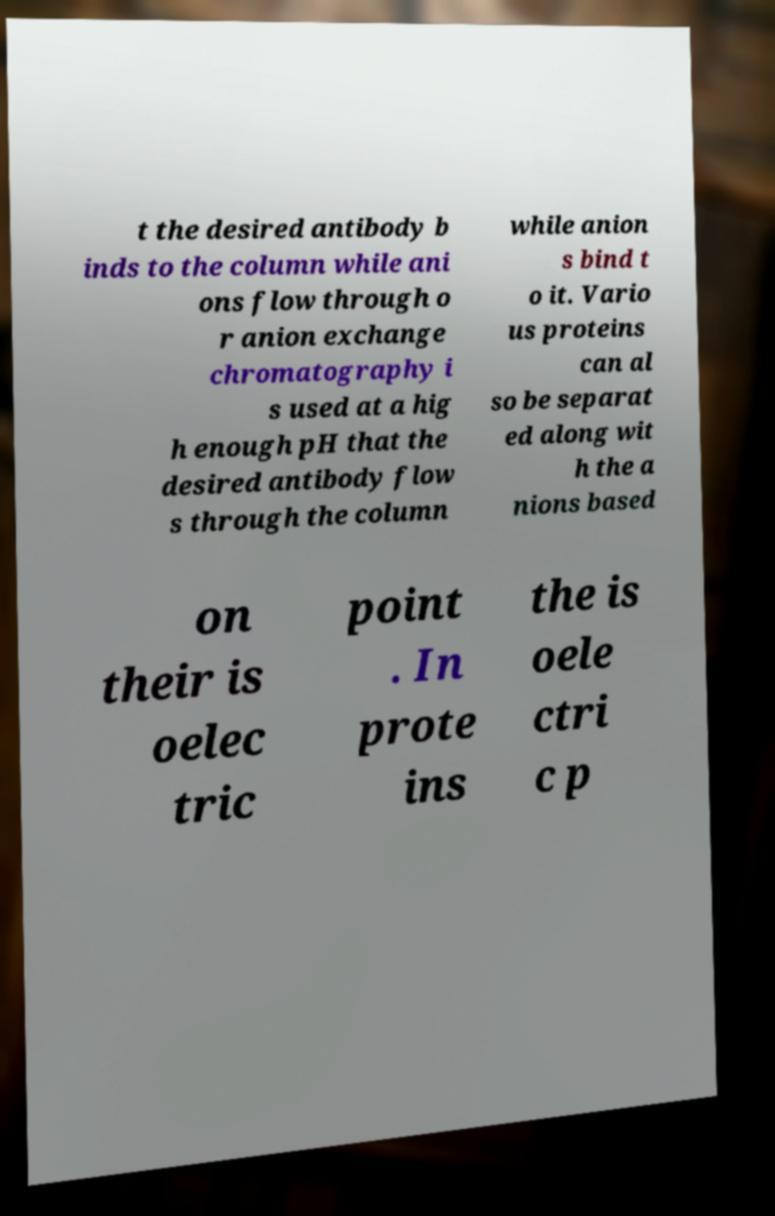Can you accurately transcribe the text from the provided image for me? t the desired antibody b inds to the column while ani ons flow through o r anion exchange chromatography i s used at a hig h enough pH that the desired antibody flow s through the column while anion s bind t o it. Vario us proteins can al so be separat ed along wit h the a nions based on their is oelec tric point . In prote ins the is oele ctri c p 